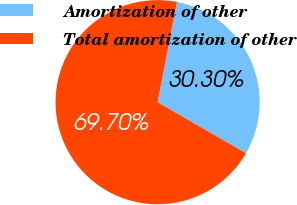Convert chart. <chart><loc_0><loc_0><loc_500><loc_500><pie_chart><fcel>Amortization of other<fcel>Total amortization of other<nl><fcel>30.3%<fcel>69.7%<nl></chart> 